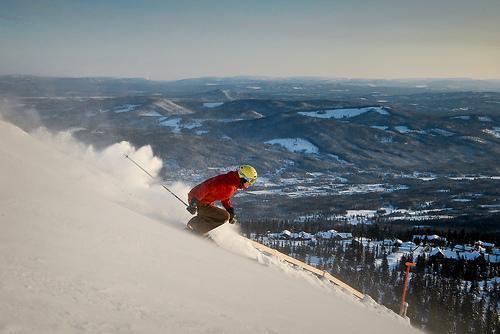How many people are there?
Give a very brief answer. 1. 